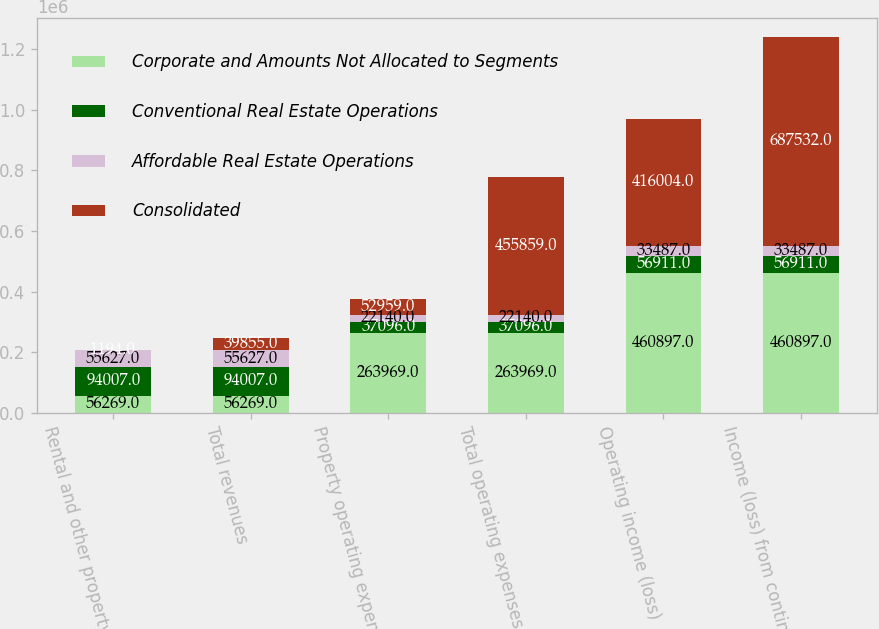<chart> <loc_0><loc_0><loc_500><loc_500><stacked_bar_chart><ecel><fcel>Rental and other property<fcel>Total revenues<fcel>Property operating expenses<fcel>Total operating expenses<fcel>Operating income (loss)<fcel>Income (loss) from continuing<nl><fcel>Corporate and Amounts Not Allocated to Segments<fcel>56269<fcel>56269<fcel>263969<fcel>263969<fcel>460897<fcel>460897<nl><fcel>Conventional Real Estate Operations<fcel>94007<fcel>94007<fcel>37096<fcel>37096<fcel>56911<fcel>56911<nl><fcel>Affordable Real Estate Operations<fcel>55627<fcel>55627<fcel>22140<fcel>22140<fcel>33487<fcel>33487<nl><fcel>Consolidated<fcel>1194<fcel>39855<fcel>52959<fcel>455859<fcel>416004<fcel>687532<nl></chart> 